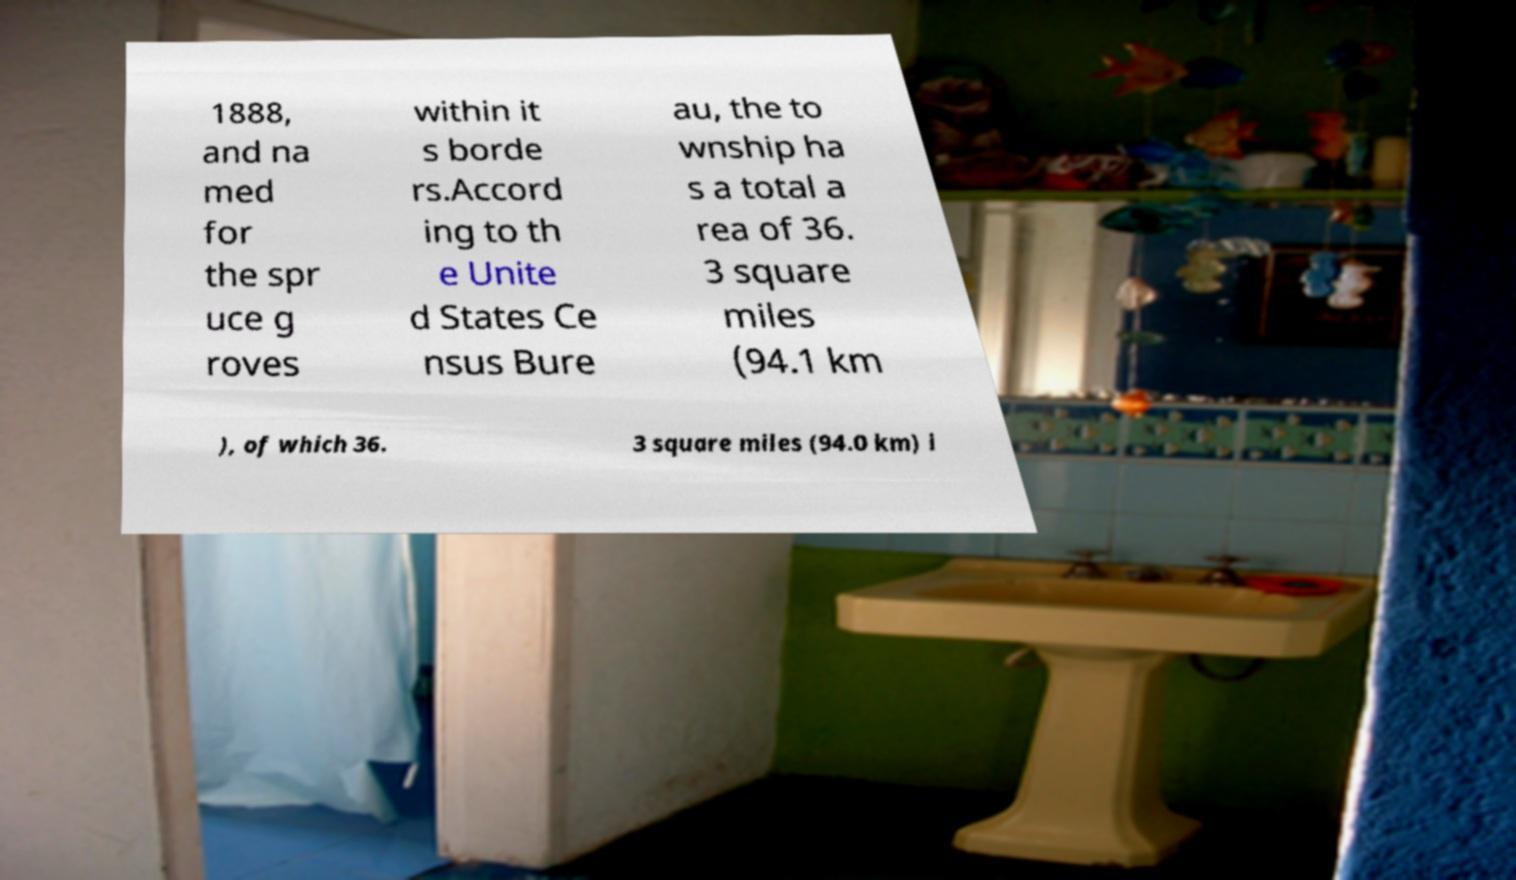Please identify and transcribe the text found in this image. 1888, and na med for the spr uce g roves within it s borde rs.Accord ing to th e Unite d States Ce nsus Bure au, the to wnship ha s a total a rea of 36. 3 square miles (94.1 km ), of which 36. 3 square miles (94.0 km) i 